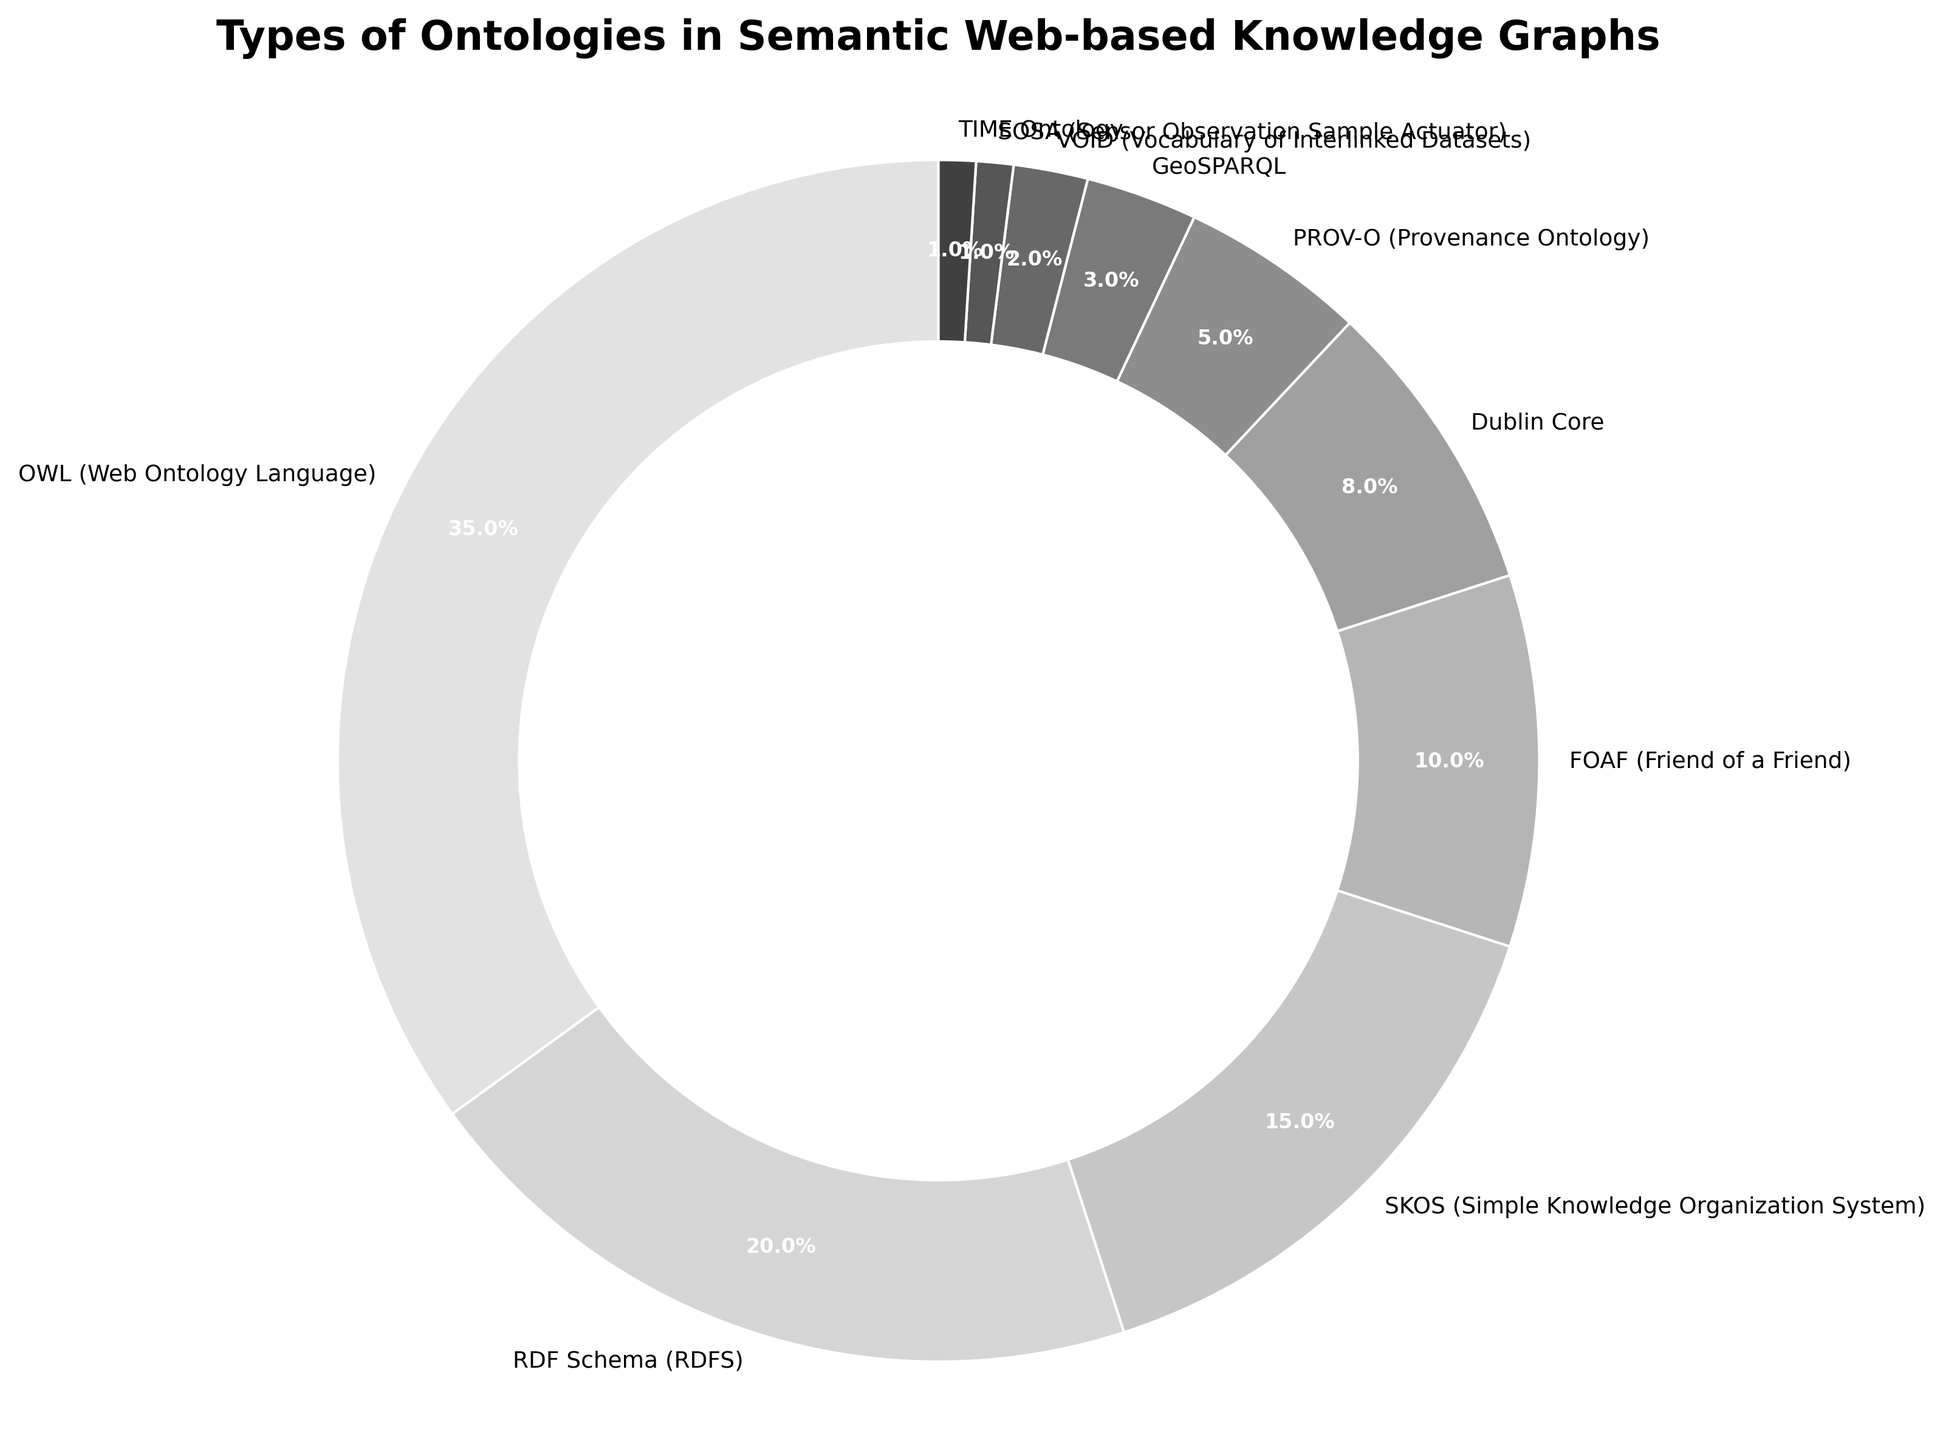Which ontology type has the highest percentage? Look at the chart and identify the largest wedge. The largest wedge represents OWL (Web Ontology Language) at 35%.
Answer: OWL (Web Ontology Language) What is the total percentage of all ontologies that have a percentage greater than 10%? Sum the percentages of OWL (35%), RDF Schema (20%), and SKOS (15%). These are the only ontologies with a percentage greater than 10%. 35 + 20 + 15 = 70%
Answer: 70% How many ontology types have a percentage less than 5%? Count the wedges that represent ontology types with less than 5%. PROV-O (5%), GeoSPARQL (3%), VOID (2%), SOSA (1%), and TIME Ontology (1%) are the relevant types. Therefore, there are 4 wedges.
Answer: 4 Which two ontology types together account for the smallest percentage, and what is that percentage? Identify the two smallest wedges and sum their percentages. The two smallest wedges are SOSA (1%) and TIME Ontology (1%), summing to 2%.
Answer: SOSA and TIME Ontology, 2% How does the percentage of FOAF compare to that of SKOS? Compare the percentages of FOAF (10%) and SKOS (15%). FOAF's percentage is smaller than SKOS's percentage.
Answer: FOAF is smaller than SKOS Are there more ontology types with percentages above 5% or below 5%? Count the number of ontology types with percentages above and below 5%. Above 5% are OWL, RDF Schema, SKOS, FOAF, and Dublin Core (5 in total). Below 5% are PROV-O, GeoSPARQL, VOID, SOSA, and TIME Ontology (5 in total). Both have the same number.
Answer: Equal What is the total percentage of ontology types classified as vocabulary of interlinked datasets? This refers to the ontology type VOID which has a percentage of 2%.
Answer: 2% If you combine the top two ontology types, what is their combined percentage? Sum the percentages of the two largest ontology types: OWL (35%) and RDF Schema (20%). 35 + 20 = 55%
Answer: 55% What is the difference in percentage between the highest and lowest ontology types? Subtract the percentage of the smallest ontology type (SOSA or TIME Ontology, 1%) from the largest one (OWL, 35%). 35 - 1 = 34%
Answer: 34% What visual feature indicates the importance of the OWL Ontology in the chart? The largest wedge represents the OWL ontology, indicating its importance by both size and position in the chart.
Answer: Largest wedge 